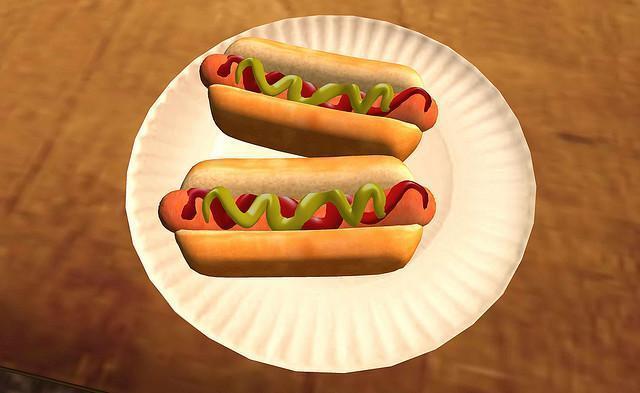How many hot dogs are visible?
Give a very brief answer. 2. 